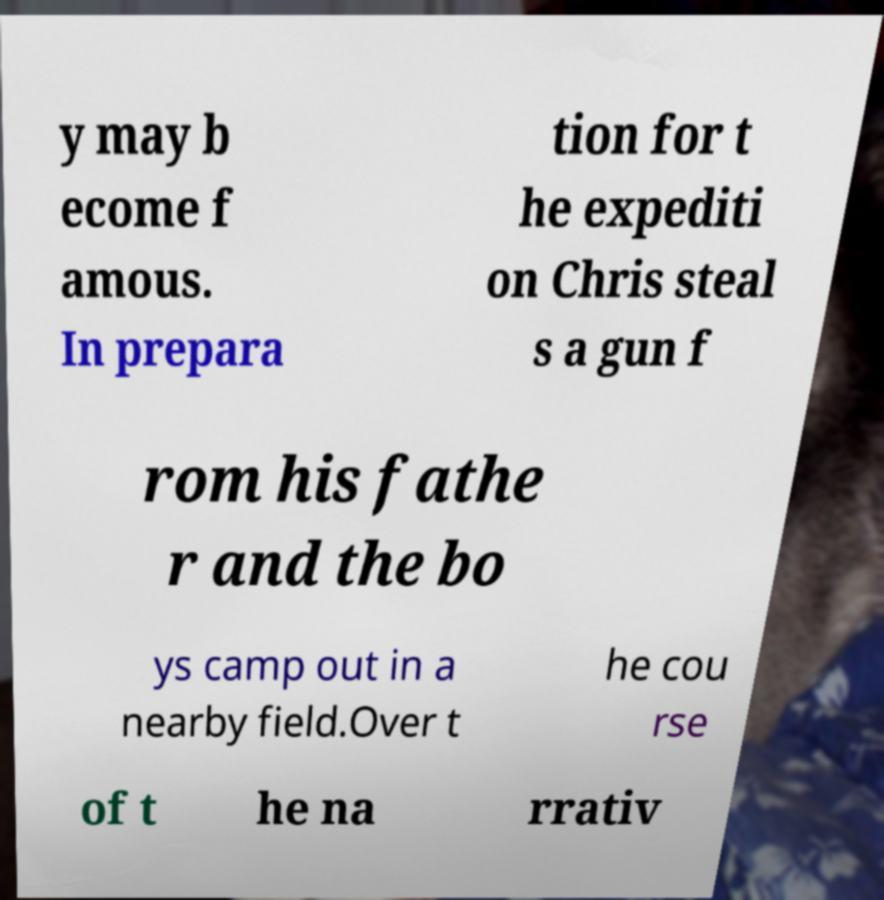Please read and relay the text visible in this image. What does it say? y may b ecome f amous. In prepara tion for t he expediti on Chris steal s a gun f rom his fathe r and the bo ys camp out in a nearby field.Over t he cou rse of t he na rrativ 